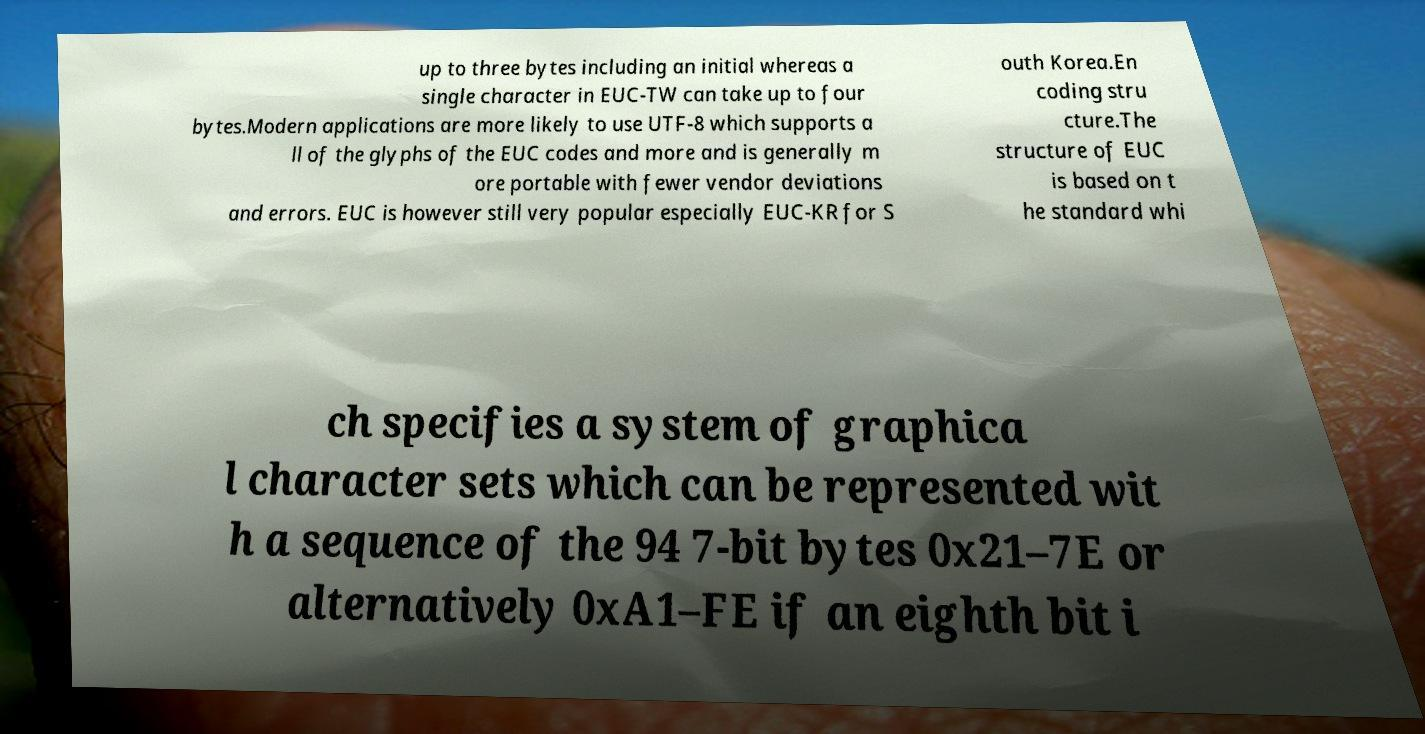Please identify and transcribe the text found in this image. up to three bytes including an initial whereas a single character in EUC-TW can take up to four bytes.Modern applications are more likely to use UTF-8 which supports a ll of the glyphs of the EUC codes and more and is generally m ore portable with fewer vendor deviations and errors. EUC is however still very popular especially EUC-KR for S outh Korea.En coding stru cture.The structure of EUC is based on t he standard whi ch specifies a system of graphica l character sets which can be represented wit h a sequence of the 94 7-bit bytes 0x21–7E or alternatively 0xA1–FE if an eighth bit i 